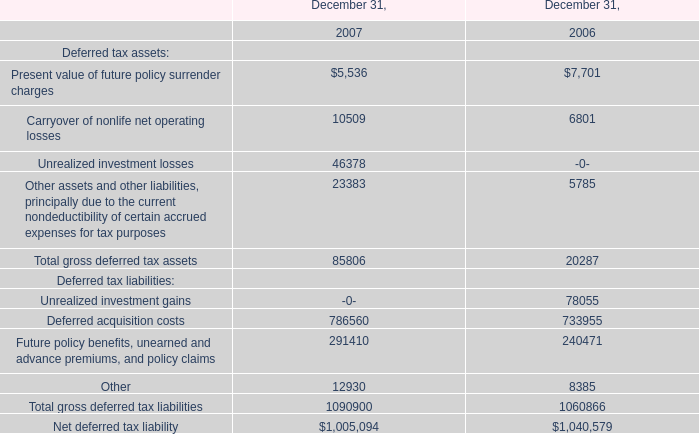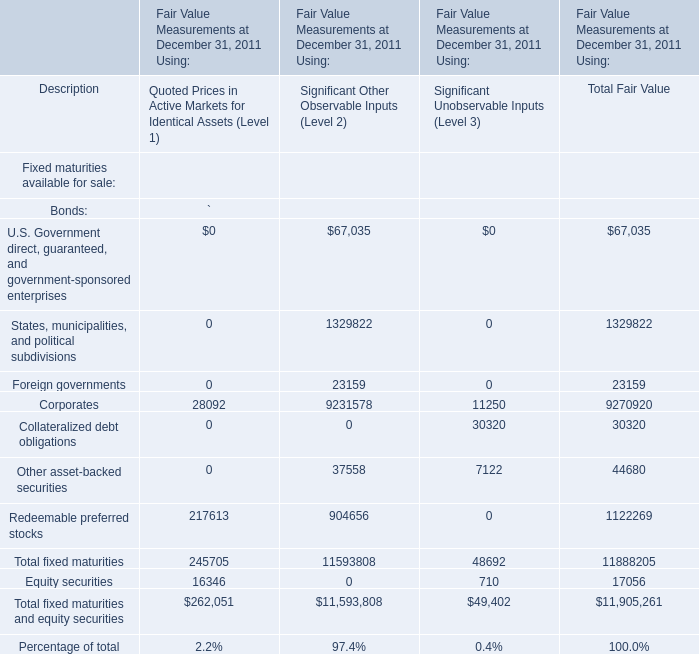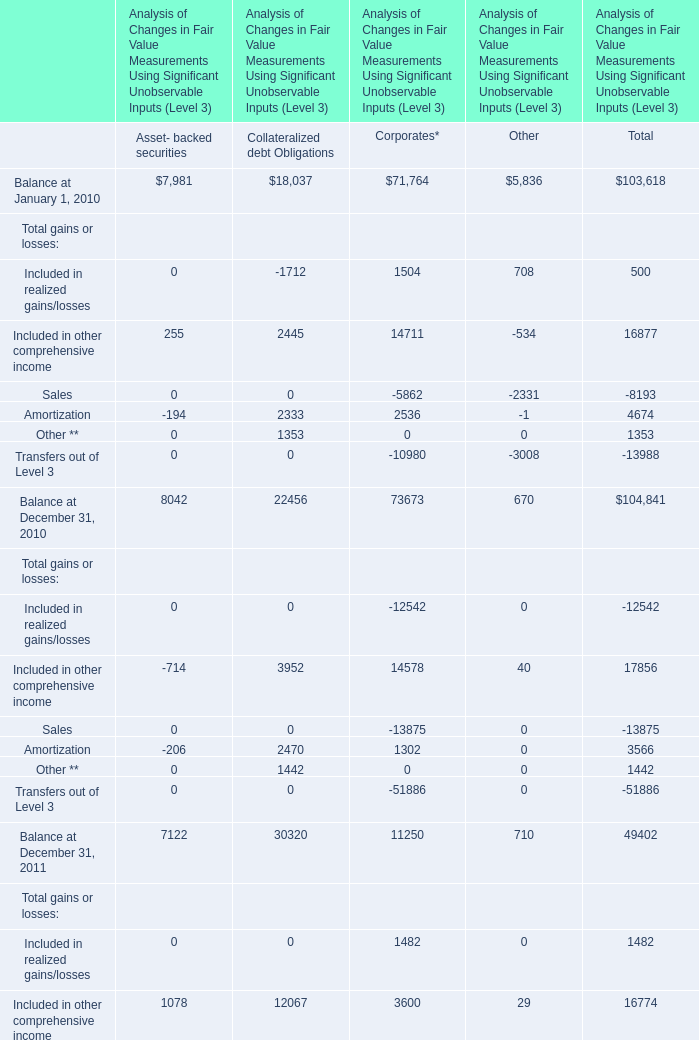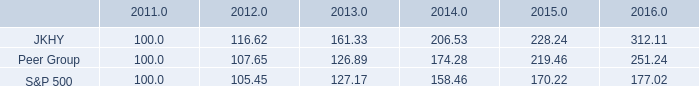What was the sum of Significant Other Observable Inputs (Level 2) without those elements greater than 50000, in 2011? 
Computations: (23159 + 37558)
Answer: 60717.0. 